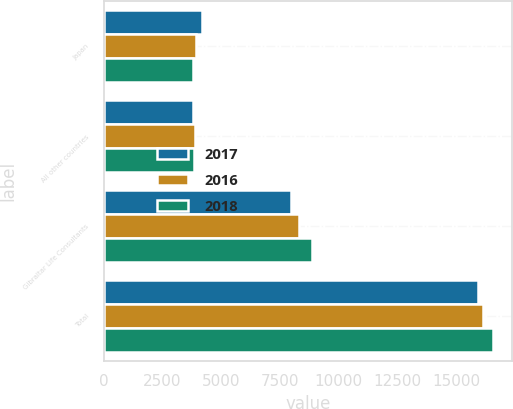Convert chart. <chart><loc_0><loc_0><loc_500><loc_500><stacked_bar_chart><ecel><fcel>Japan<fcel>All other countries<fcel>Gibraltar Life Consultants<fcel>Total<nl><fcel>2017<fcel>4183<fcel>3786<fcel>7964<fcel>15933<nl><fcel>2016<fcel>3941<fcel>3890<fcel>8326<fcel>16157<nl><fcel>2018<fcel>3824<fcel>3856<fcel>8884<fcel>16564<nl></chart> 